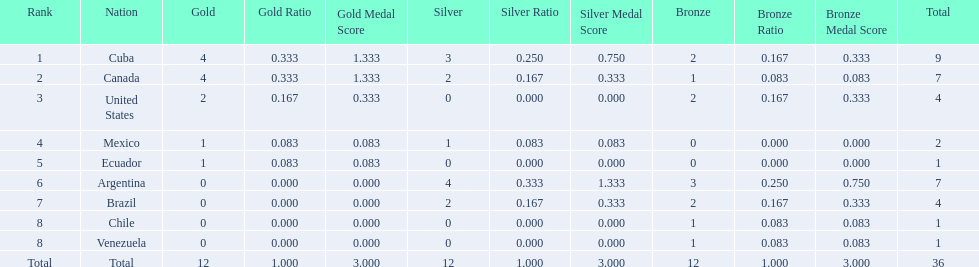Which nations participated? Cuba, Canada, United States, Mexico, Ecuador, Argentina, Brazil, Chile, Venezuela. Which nations won gold? Cuba, Canada, United States, Mexico, Ecuador. Which nations did not win silver? United States, Ecuador, Chile, Venezuela. Out of those countries previously listed, which nation won gold? United States. 